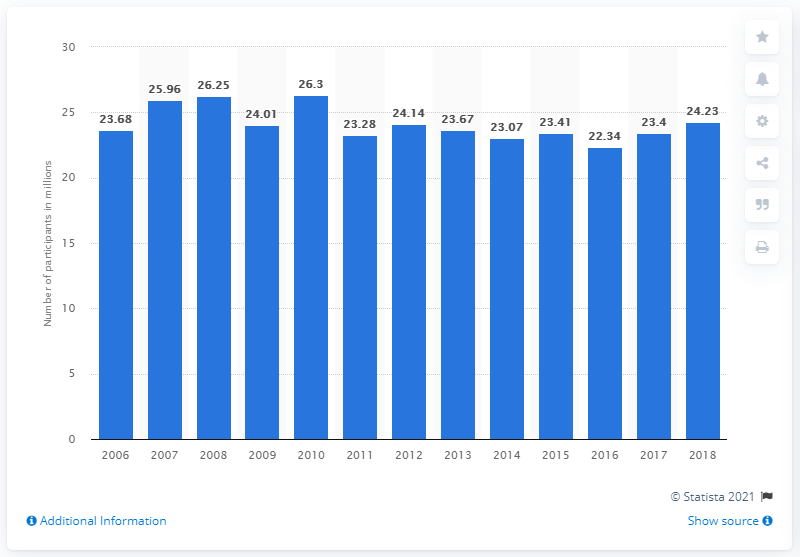Mention a couple of crucial points in this snapshot. In 2018, the total number of participants in basketball in the United States was 24.23 million. 